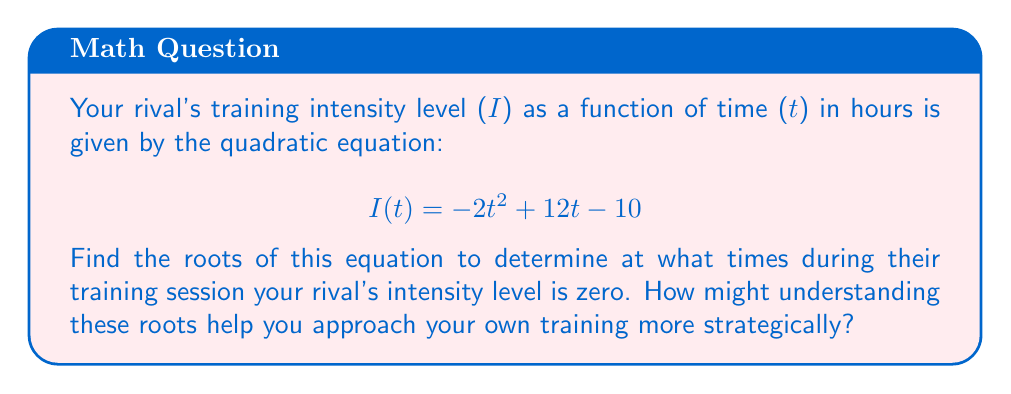Give your solution to this math problem. To find the roots of the quadratic equation, we need to solve:

$$ -2t^2 + 12t - 10 = 0 $$

We can use the quadratic formula: $t = \frac{-b \pm \sqrt{b^2 - 4ac}}{2a}$

Where $a = -2$, $b = 12$, and $c = -10$

Step 1: Calculate the discriminant
$$ b^2 - 4ac = 12^2 - 4(-2)(-10) = 144 - 80 = 64 $$

Step 2: Apply the quadratic formula
$$ t = \frac{-12 \pm \sqrt{64}}{2(-2)} = \frac{-12 \pm 8}{-4} $$

Step 3: Simplify
$$ t = \frac{-12 + 8}{-4} \text{ or } \frac{-12 - 8}{-4} $$
$$ t = \frac{-4}{-4} \text{ or } \frac{-20}{-4} $$
$$ t = 1 \text{ or } 5 $$

Understanding these roots can help you strategize your own training. The roots indicate that your rival's intensity starts at zero, increases to a peak, and then returns to zero after 5 hours. This suggests they might have a more aggressive, "burn-out" style of training, which you could contrast with a more sustainable approach.
Answer: The roots of the equation are $t = 1$ and $t = 5$, meaning your rival's training intensity is zero at 1 hour and 5 hours into their session. 